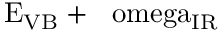<formula> <loc_0><loc_0><loc_500><loc_500>E _ { V B } + \hbar { \ } o m e g a _ { I R }</formula> 